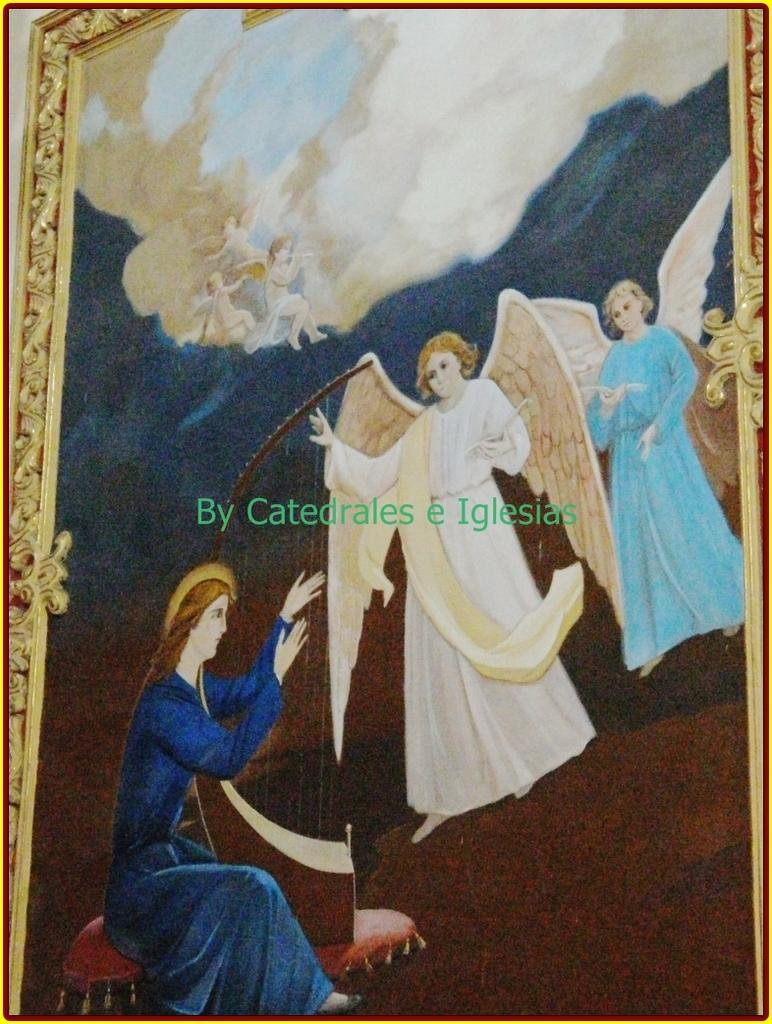What is featured in the image? There is a poster in the image. Can you describe the poster? The poster has two angles. What is the man in the image doing? The man is sitting down in the image. What type of fuel is being used by the man in the image? There is no indication in the image that the man is using any type of fuel, as he is simply sitting down. 